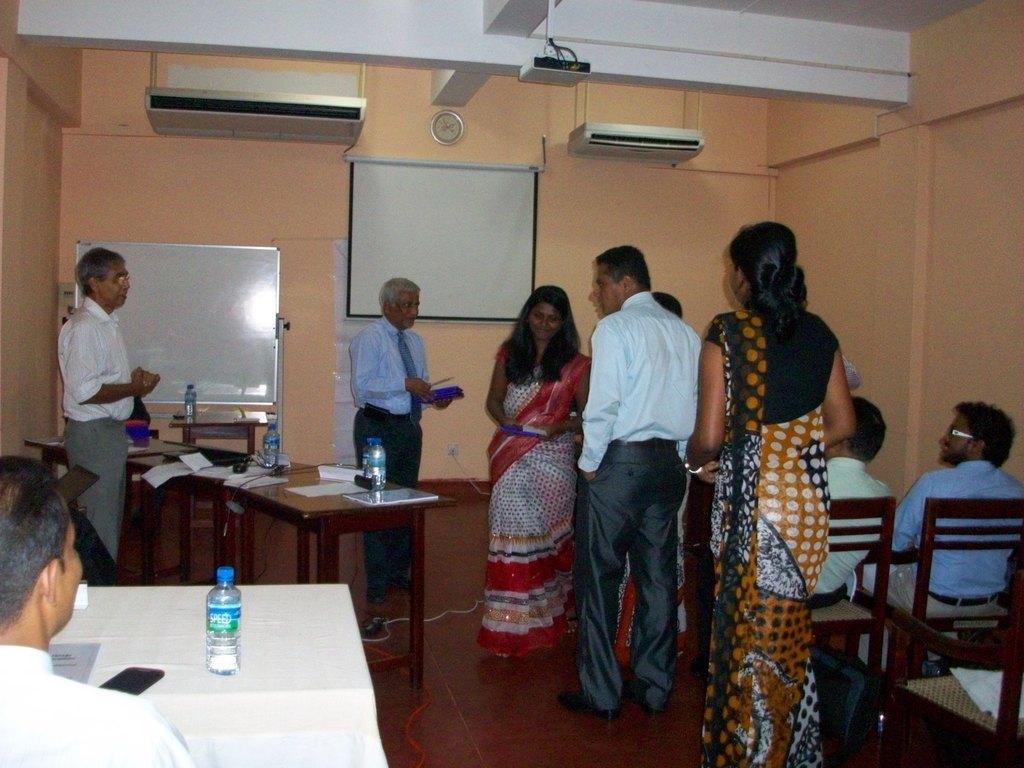In one or two sentences, can you explain what this image depicts? in the picture there are many people some people are sitting and some people are standing there is also a table in front of them on the table there are many items such as bottles,books e. t. c. 